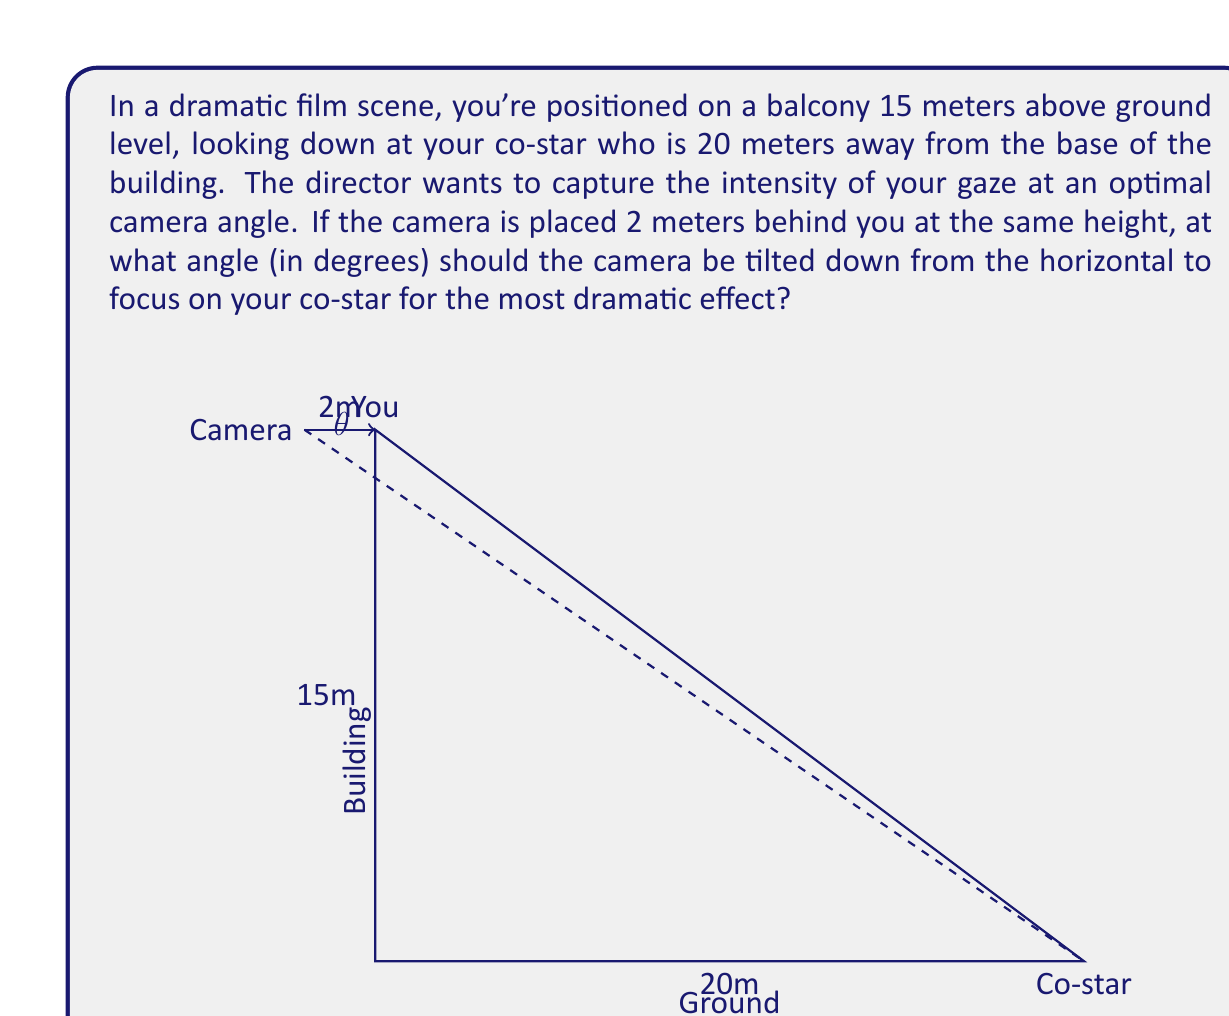Can you solve this math problem? Let's approach this step-by-step:

1) First, we need to find the angle between the horizontal line from the camera and the line connecting the camera to the co-star.

2) We can use trigonometry to solve this problem. We'll be working with a right triangle where:
   - The base is the horizontal distance from the camera to the co-star (20 + 2 = 22 meters)
   - The height is the vertical distance from the camera to the ground (15 meters)

3) Let's call our desired angle $\theta$. We can use the tangent function to find this angle:

   $$\tan(\theta) = \frac{\text{opposite}}{\text{adjacent}} = \frac{15}{22}$$

4) To solve for $\theta$, we need to use the inverse tangent (arctangent) function:

   $$\theta = \arctan(\frac{15}{22})$$

5) Using a calculator or programming function, we can compute this value:

   $$\theta \approx 0.5993 \text{ radians}$$

6) However, the question asks for the answer in degrees. To convert from radians to degrees, we multiply by $\frac{180}{\pi}$:

   $$\theta \approx 0.5993 \times \frac{180}{\pi} \approx 34.33\text{ degrees}$$

7) Rounding to two decimal places for precision, we get our final answer.
Answer: 34.33° 